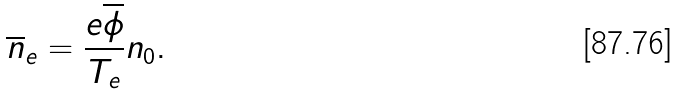<formula> <loc_0><loc_0><loc_500><loc_500>\overline { n } _ { e } = \frac { e \overline { \phi } } { T _ { e } } n _ { 0 } .</formula> 